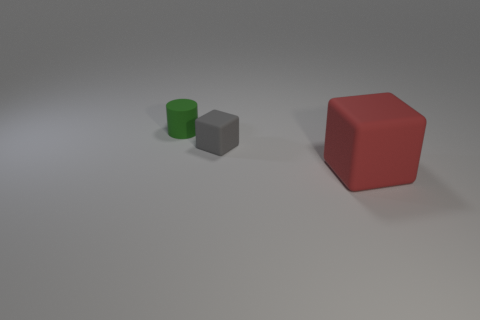There is a matte object that is both right of the green cylinder and behind the big red matte cube; what shape is it? The object you're referring to is a matte grey cube. Situated to the right of the green cylinder and behind the larger red cube, its distinct edges and identical faces distinguish it as a cube. 